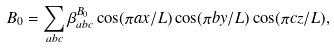<formula> <loc_0><loc_0><loc_500><loc_500>B _ { 0 } = \sum _ { a b c } \beta ^ { B _ { 0 } } _ { a b c } \cos ( \pi a x / L ) \cos ( \pi b y / L ) \cos ( \pi c z / L ) ,</formula> 